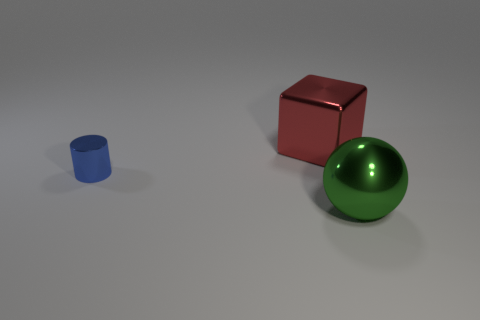Add 1 tiny cyan matte cylinders. How many objects exist? 4 Subtract all balls. How many objects are left? 2 Add 3 green shiny things. How many green shiny things exist? 4 Subtract 0 cyan spheres. How many objects are left? 3 Subtract all large rubber spheres. Subtract all green things. How many objects are left? 2 Add 3 big shiny blocks. How many big shiny blocks are left? 4 